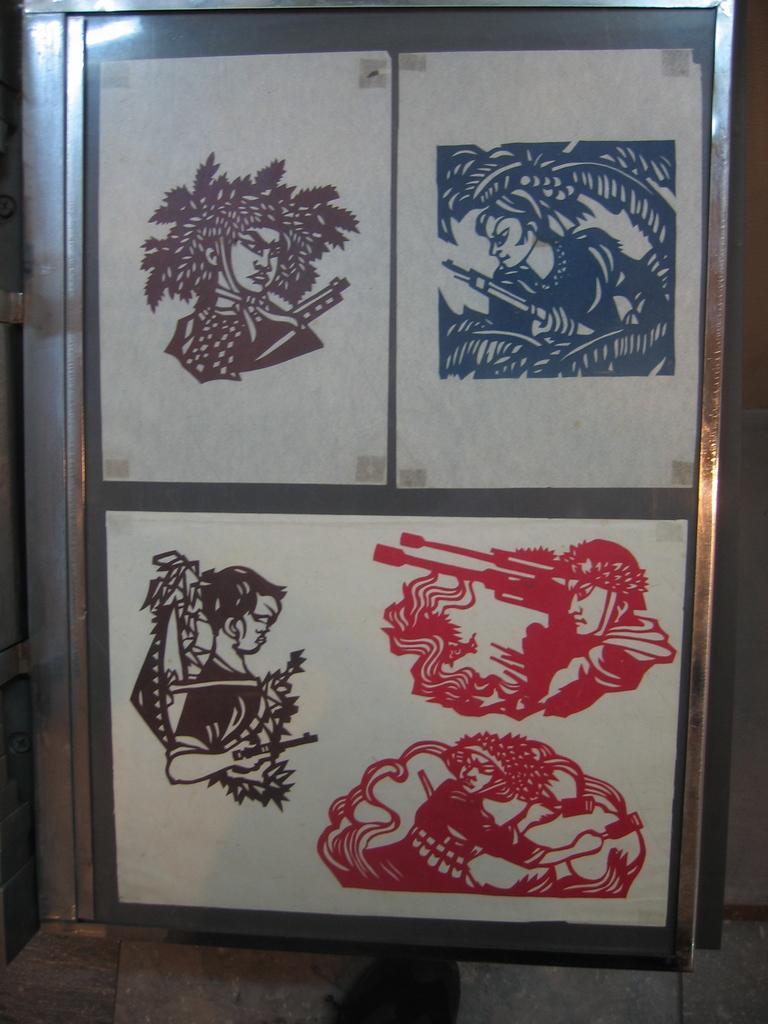Could you give a brief overview of what you see in this image? In this image we can see there is a painting of a few people on the door of the cupboard. 